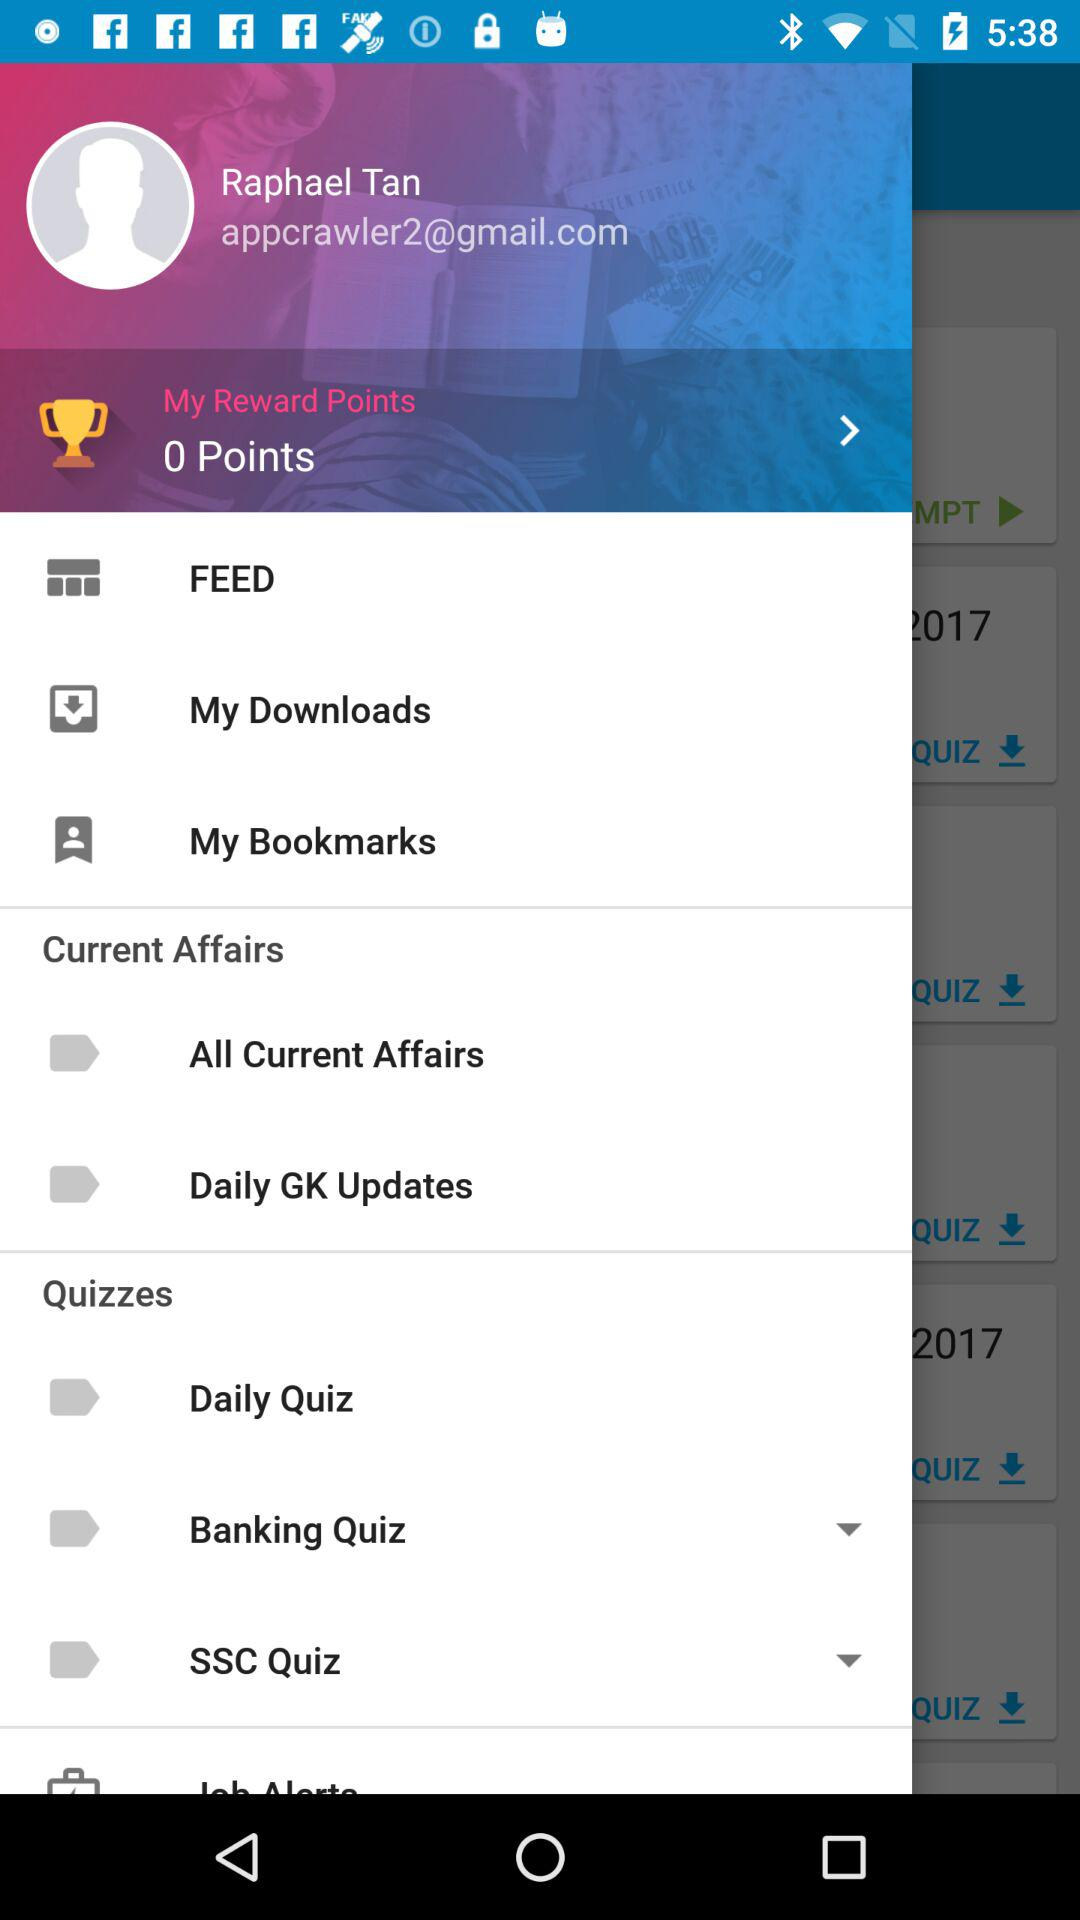How many reward points are shown on the screen? There are 0 reward points shown on the screen. 